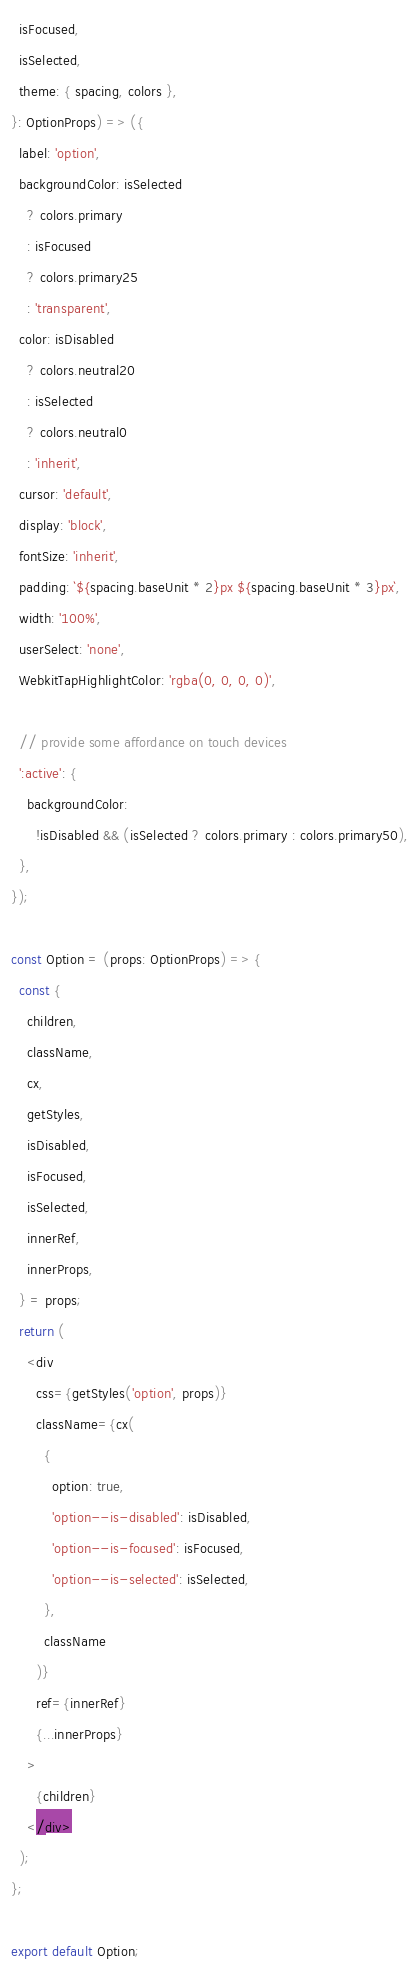<code> <loc_0><loc_0><loc_500><loc_500><_JavaScript_>  isFocused,
  isSelected,
  theme: { spacing, colors },
}: OptionProps) => ({
  label: 'option',
  backgroundColor: isSelected
    ? colors.primary
    : isFocused
    ? colors.primary25
    : 'transparent',
  color: isDisabled
    ? colors.neutral20
    : isSelected
    ? colors.neutral0
    : 'inherit',
  cursor: 'default',
  display: 'block',
  fontSize: 'inherit',
  padding: `${spacing.baseUnit * 2}px ${spacing.baseUnit * 3}px`,
  width: '100%',
  userSelect: 'none',
  WebkitTapHighlightColor: 'rgba(0, 0, 0, 0)',

  // provide some affordance on touch devices
  ':active': {
    backgroundColor:
      !isDisabled && (isSelected ? colors.primary : colors.primary50),
  },
});

const Option = (props: OptionProps) => {
  const {
    children,
    className,
    cx,
    getStyles,
    isDisabled,
    isFocused,
    isSelected,
    innerRef,
    innerProps,
  } = props;
  return (
    <div
      css={getStyles('option', props)}
      className={cx(
        {
          option: true,
          'option--is-disabled': isDisabled,
          'option--is-focused': isFocused,
          'option--is-selected': isSelected,
        },
        className
      )}
      ref={innerRef}
      {...innerProps}
    >
      {children}
    </div>
  );
};

export default Option;
</code> 